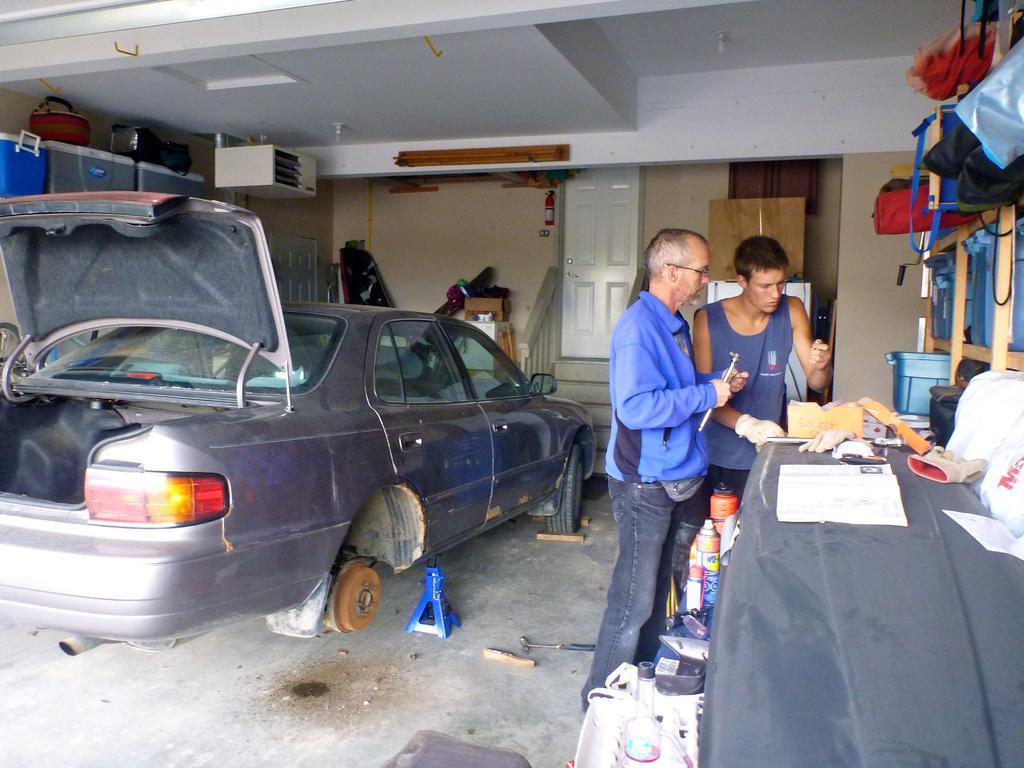In one or two sentences, can you explain what this image depicts? In the image we can see there are people standing and a man is holding small iron rod in his hand. There is car parked on the ground and there are spray bottles and there is a bag kept on the shelf. Behind there is a door and there are stairs. 